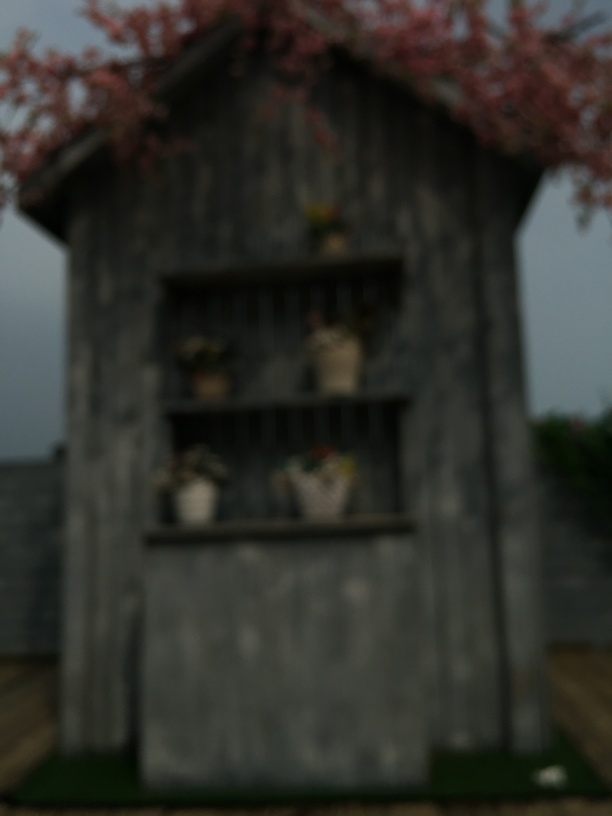What kind of building is shown in this image? The building appears to be a traditional structure, possibly a barn or a rustic-style shed, with openings that might be used for storage. 